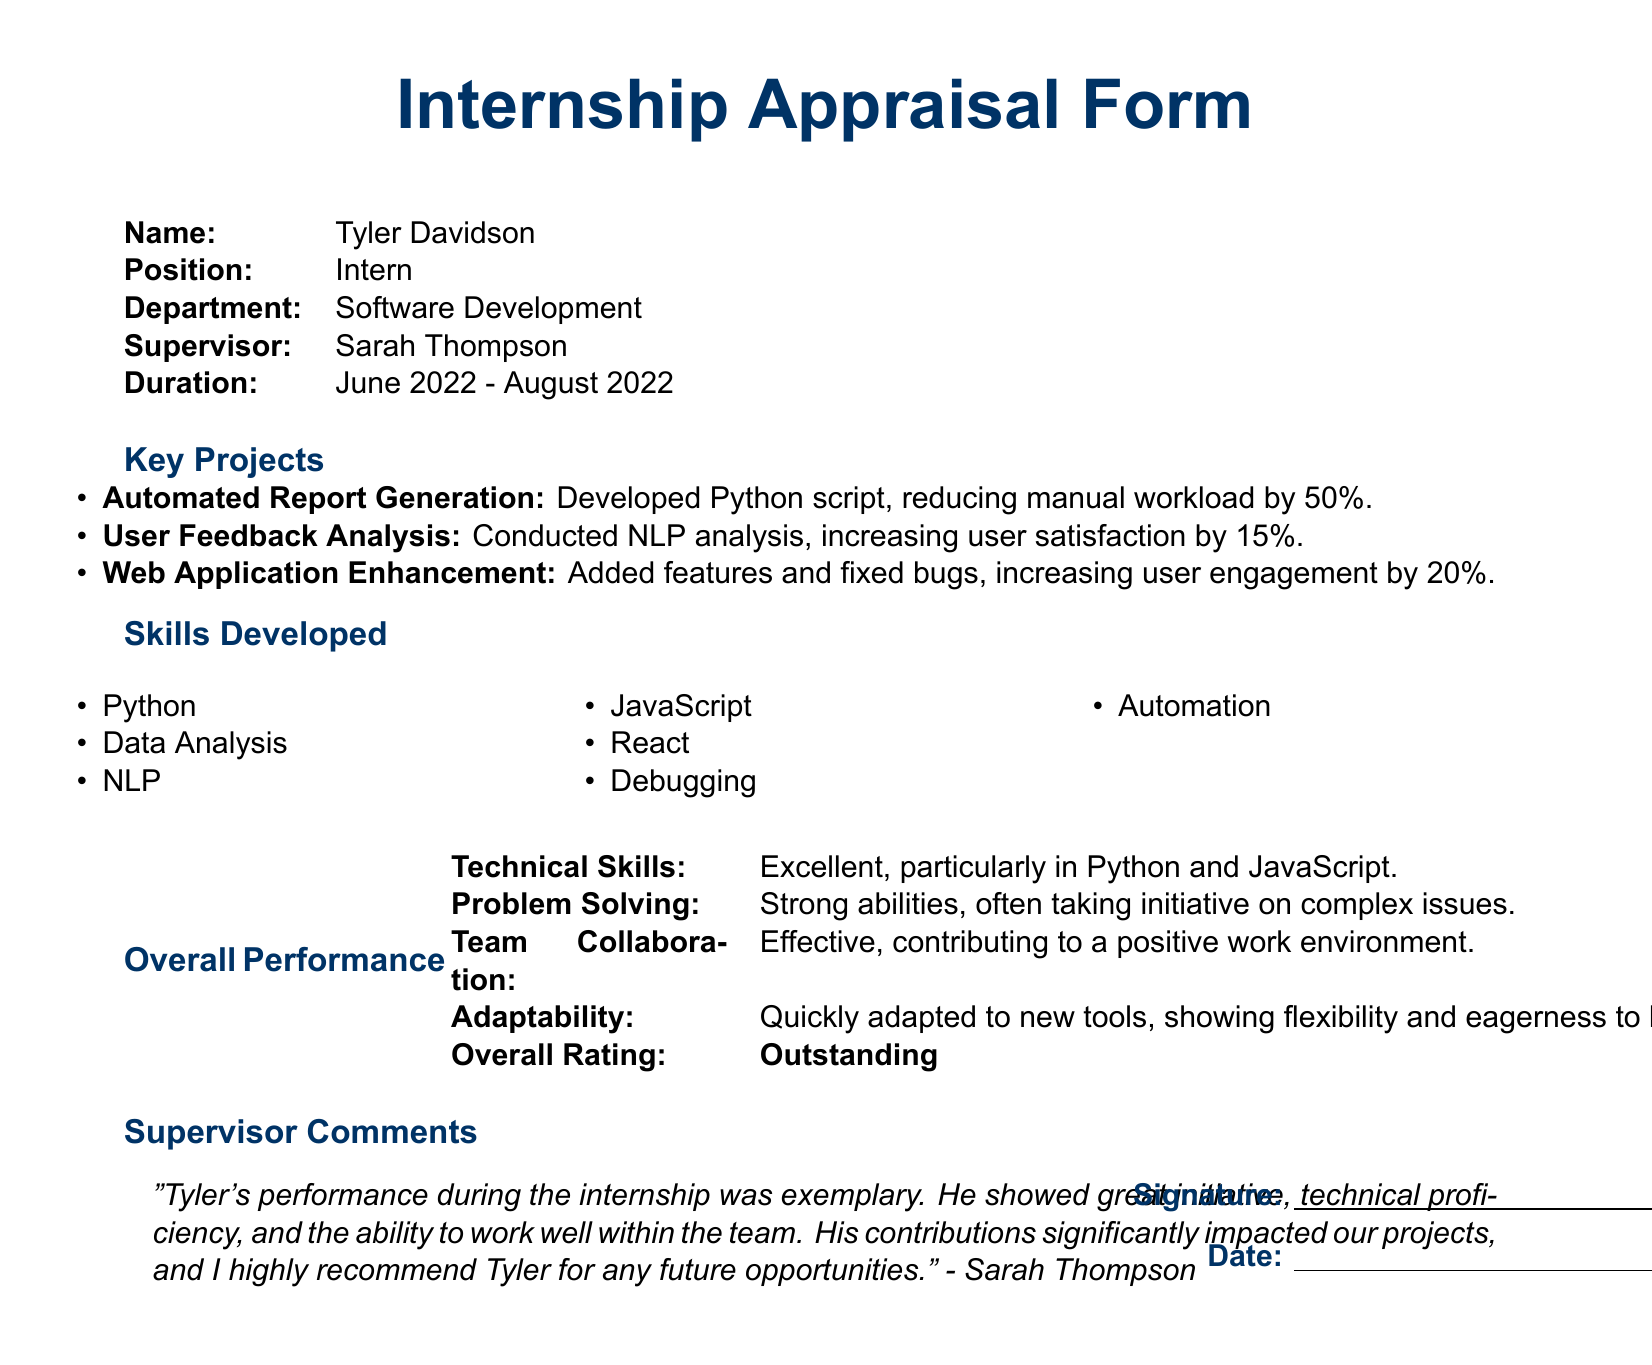What is Tyler's position during the internship? The document states that Tyler held the position of Intern in the Software Development department.
Answer: Intern Who was Tyler's supervisor? The supervisor listed in the document is Sarah Thompson.
Answer: Sarah Thompson What was the duration of Tyler's internship? The internship lasted from June 2022 to August 2022, as noted in the document.
Answer: June 2022 - August 2022 What percentage did the Automated Report Generation project reduce manual workload? The document indicates a 50% reduction in manual workload due to the project.
Answer: 50% Which skill is related to increasing user satisfaction by analyzing feedback? The project that involved conducting analysis to increase satisfaction is related to NLP, as mentioned in the key projects section.
Answer: NLP How did Tyler demonstrate adaptability during the internship? The document highlights Tyler's ability to quickly adapt to new tools and shows eagerness to learn.
Answer: Quickly adapted to new tools What overall rating did Tyler receive for his performance? The overall performance rating in the appraisal form is classified as Outstanding.
Answer: Outstanding What was one of Tyler's key projects focused on enhancing user engagement? The key project that aimed to increase user engagement by 20% was the Web Application Enhancement.
Answer: Web Application Enhancement What technical skills did Tyler excel in according to the document? The appraisal form explicitly mentions Tyler excelled in technical skills, particularly in Python and JavaScript.
Answer: Python and JavaScript What type of document is this? The document is an Internship Appraisal Form specifically evaluating Tyler's experience and contributions during his internship.
Answer: Internship Appraisal Form 